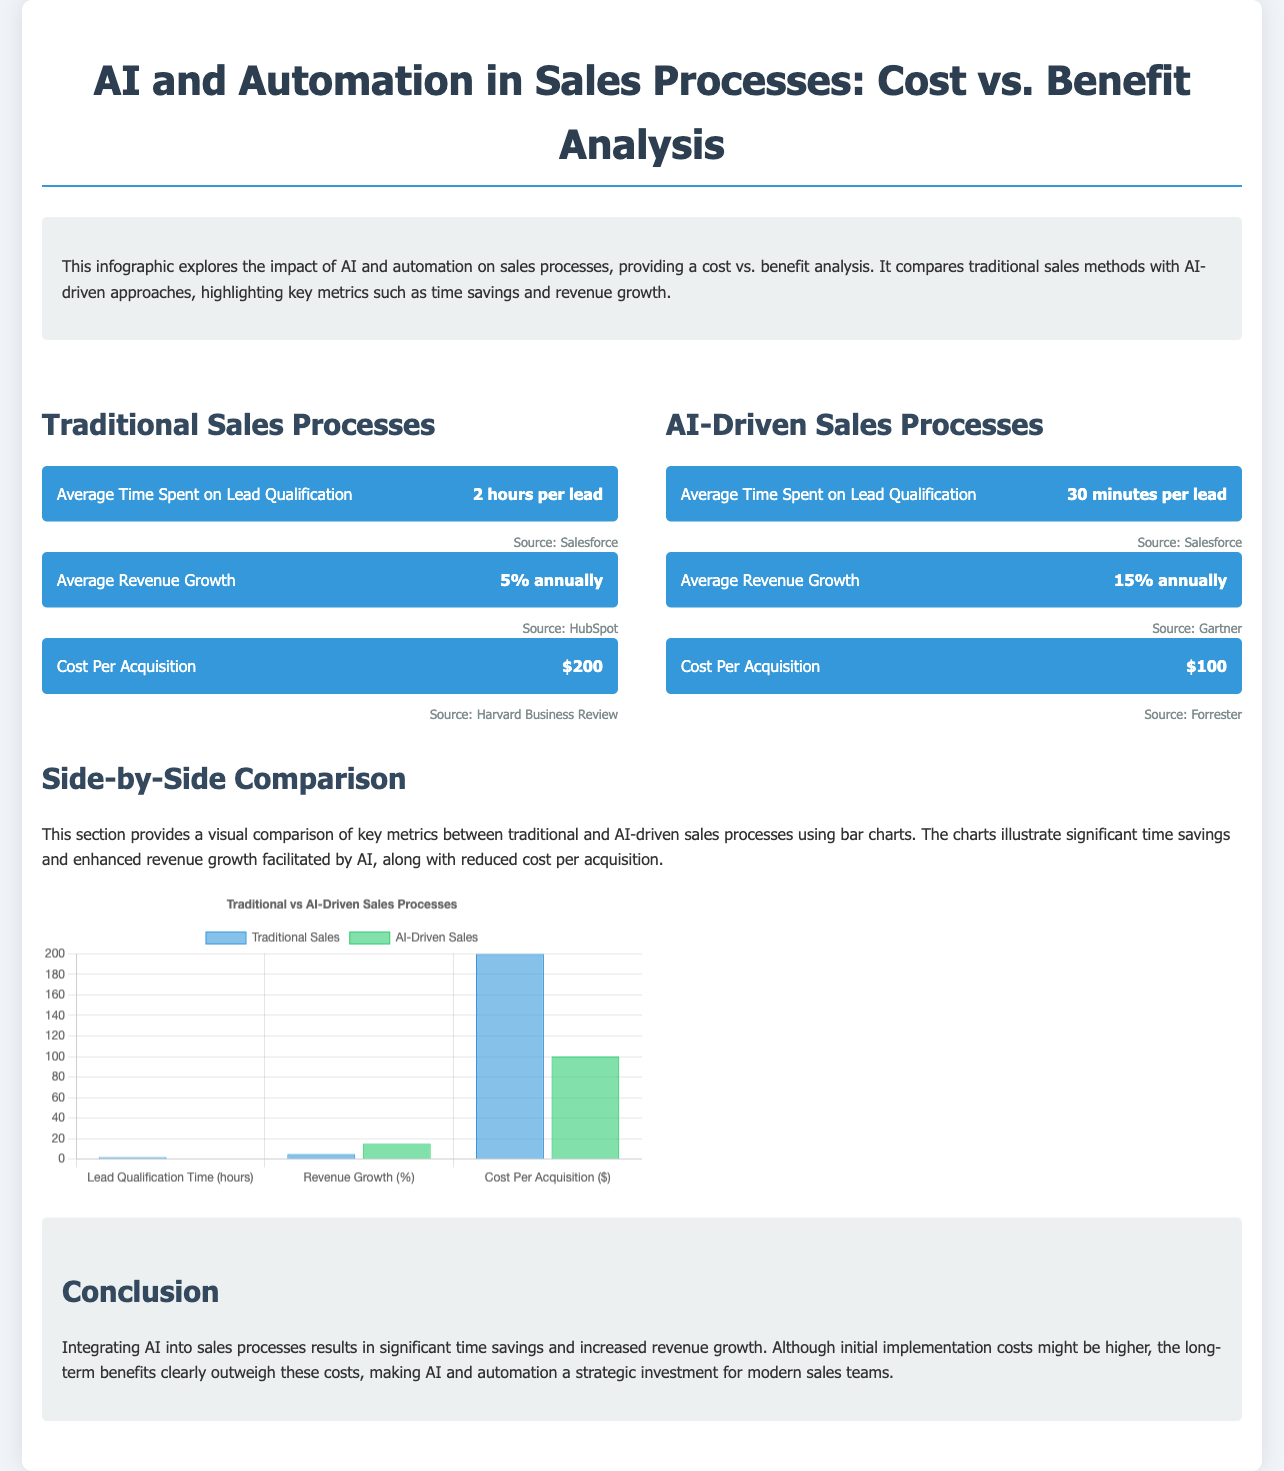what is the average time spent on lead qualification in traditional sales processes? The document states that the average time spent on lead qualification in traditional sales processes is 2 hours per lead.
Answer: 2 hours per lead what is the average revenue growth for AI-driven sales processes? According to the document, the average revenue growth for AI-driven sales processes is 15% annually.
Answer: 15% annually what is the cost per acquisition for traditional sales processes? The document indicates that the cost per acquisition for traditional sales processes is $200.
Answer: $200 how much time is saved in lead qualification when using AI-driven processes? The reduction in lead qualification time from 2 hours to 30 minutes signifies a savings of 1.5 hours per lead.
Answer: 1.5 hours how much is the cost per acquisition reduced from traditional to AI-driven sales processes? The decrease in cost per acquisition from $200 to $100 represents a savings of $100.
Answer: $100 what is the primary benefit of AI and automation in sales processes mentioned in the conclusion? The conclusion highlights that integrating AI yields significant time savings and increased revenue growth.
Answer: time savings and increased revenue growth which source provides the revenue growth percentage for traditional sales processes? The source for the average revenue growth in traditional sales processes is HubSpot.
Answer: HubSpot what type of comparisons does the chart provide? The chart provides side-by-side comparisons of key metrics between traditional and AI-driven sales processes.
Answer: side-by-side comparisons what is the background color of the AI-driven sales dataset in the chart? The background color of the AI-driven sales dataset is rgba(46, 204, 113, 0.6).
Answer: rgba(46, 204, 113, 0.6) 